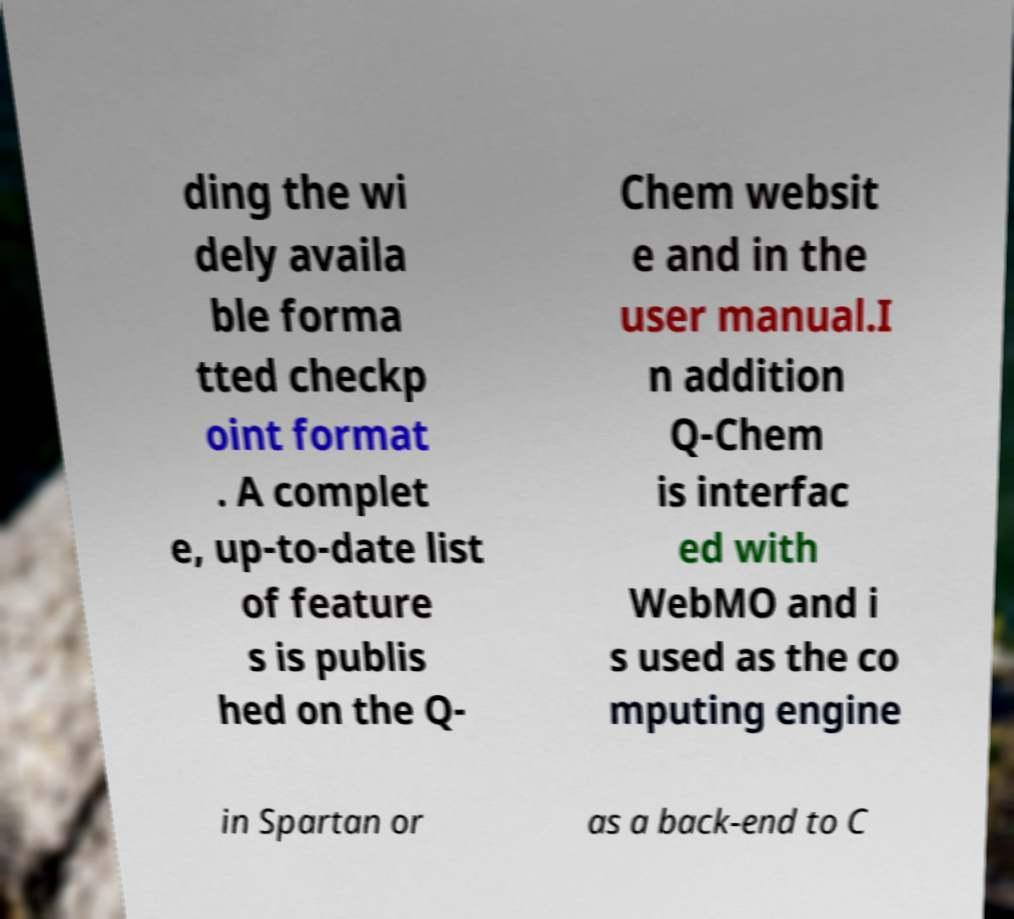What messages or text are displayed in this image? I need them in a readable, typed format. ding the wi dely availa ble forma tted checkp oint format . A complet e, up-to-date list of feature s is publis hed on the Q- Chem websit e and in the user manual.I n addition Q-Chem is interfac ed with WebMO and i s used as the co mputing engine in Spartan or as a back-end to C 